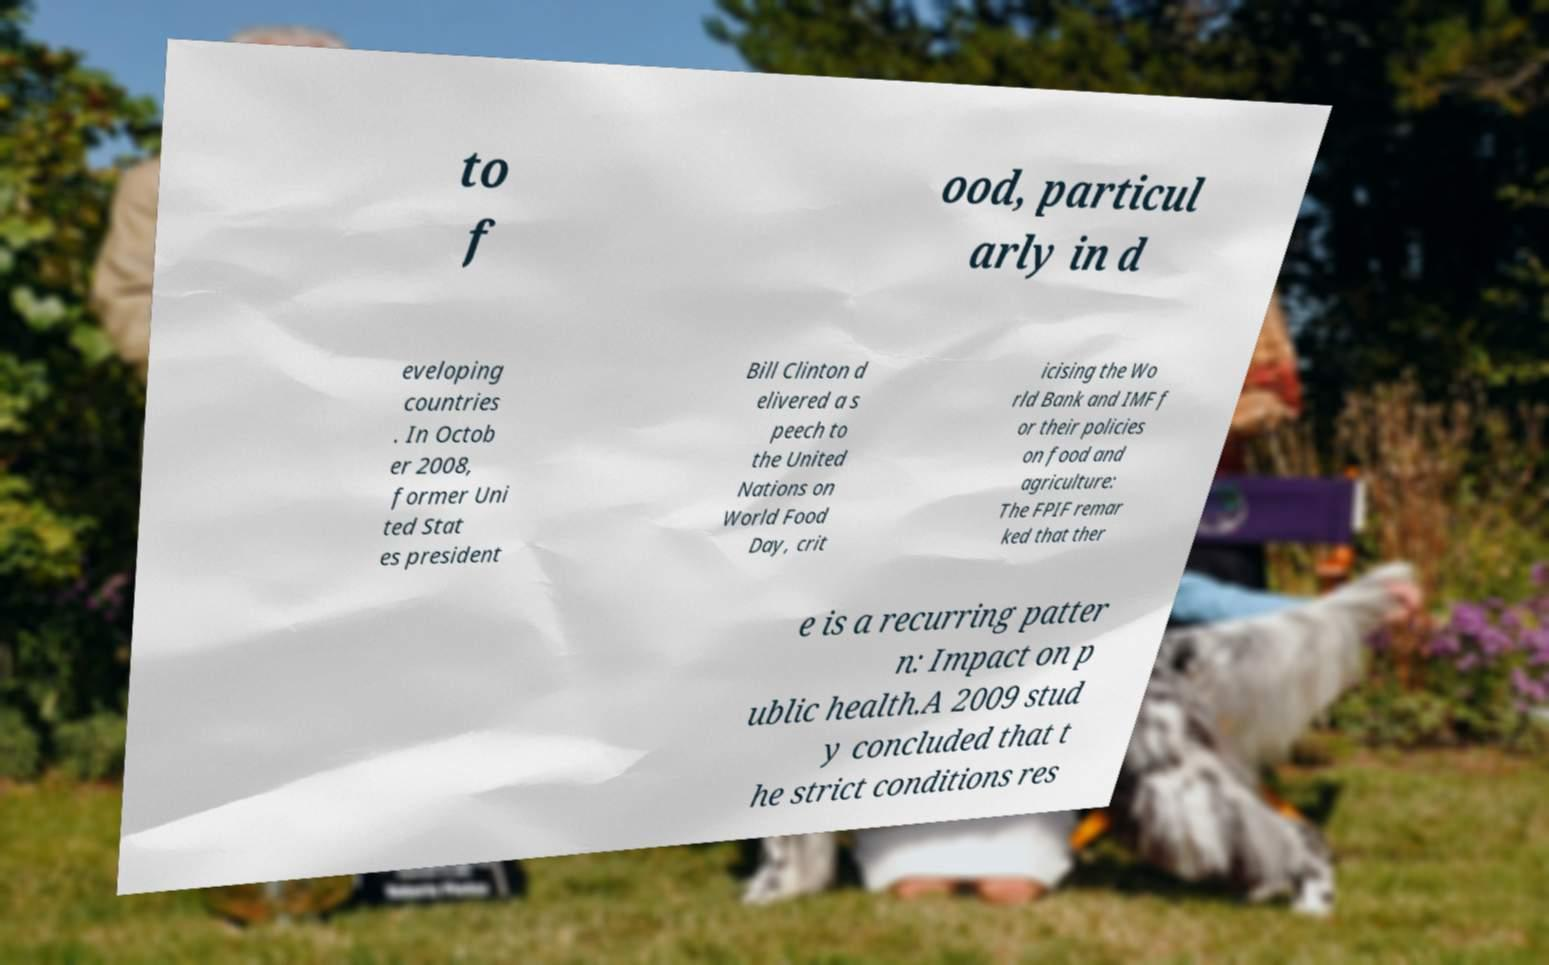There's text embedded in this image that I need extracted. Can you transcribe it verbatim? to f ood, particul arly in d eveloping countries . In Octob er 2008, former Uni ted Stat es president Bill Clinton d elivered a s peech to the United Nations on World Food Day, crit icising the Wo rld Bank and IMF f or their policies on food and agriculture: The FPIF remar ked that ther e is a recurring patter n: Impact on p ublic health.A 2009 stud y concluded that t he strict conditions res 